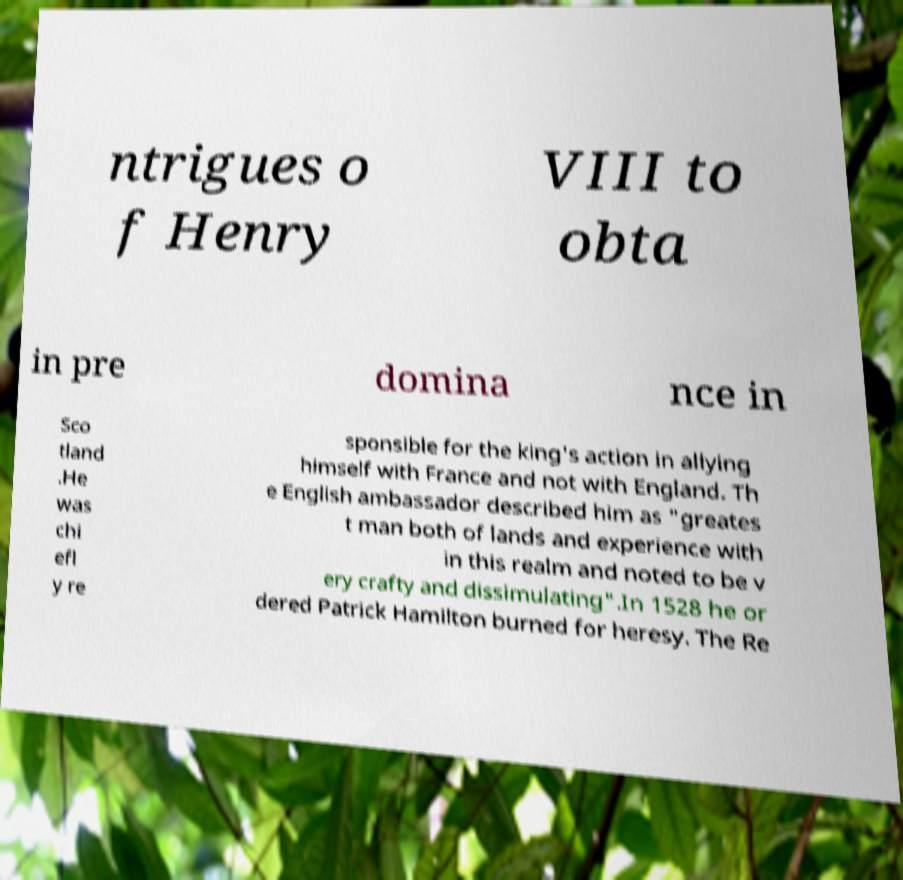Please identify and transcribe the text found in this image. ntrigues o f Henry VIII to obta in pre domina nce in Sco tland .He was chi efl y re sponsible for the king's action in allying himself with France and not with England. Th e English ambassador described him as "greates t man both of lands and experience with in this realm and noted to be v ery crafty and dissimulating".In 1528 he or dered Patrick Hamilton burned for heresy. The Re 